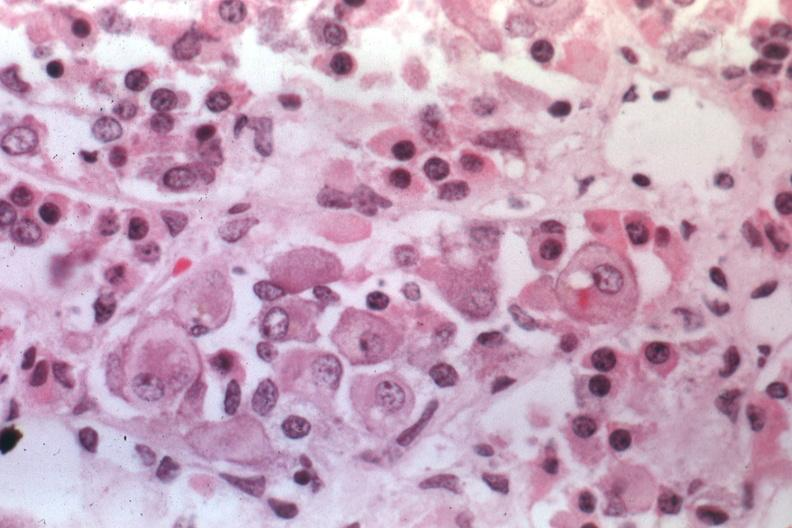what is present?
Answer the question using a single word or phrase. Pituitary 